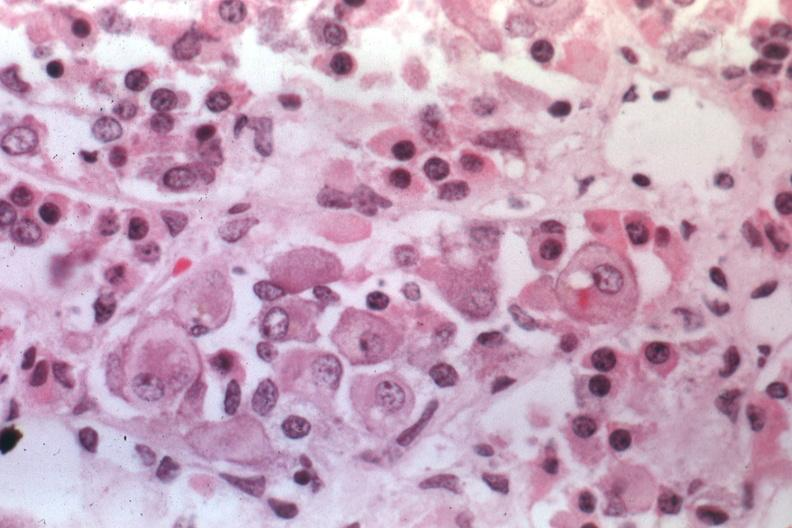what is present?
Answer the question using a single word or phrase. Pituitary 